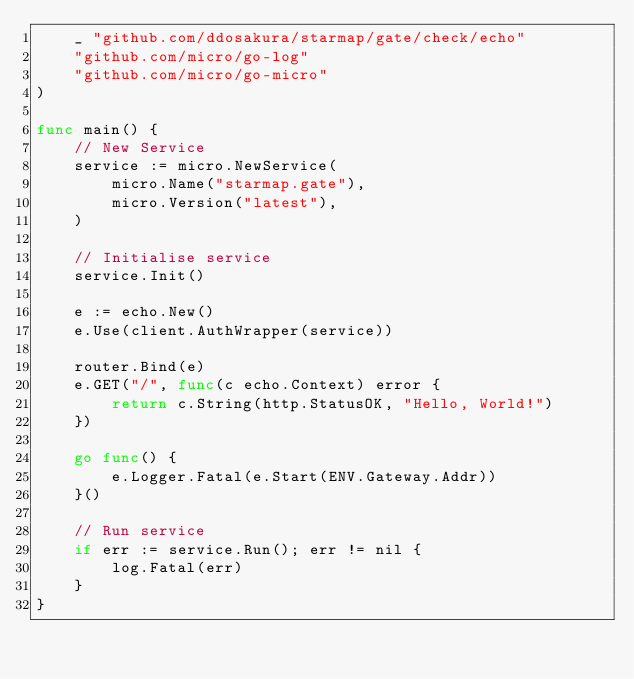<code> <loc_0><loc_0><loc_500><loc_500><_Go_>	_ "github.com/ddosakura/starmap/gate/check/echo"
	"github.com/micro/go-log"
	"github.com/micro/go-micro"
)

func main() {
	// New Service
	service := micro.NewService(
		micro.Name("starmap.gate"),
		micro.Version("latest"),
	)

	// Initialise service
	service.Init()

	e := echo.New()
	e.Use(client.AuthWrapper(service))

	router.Bind(e)
	e.GET("/", func(c echo.Context) error {
		return c.String(http.StatusOK, "Hello, World!")
	})

	go func() {
		e.Logger.Fatal(e.Start(ENV.Gateway.Addr))
	}()

	// Run service
	if err := service.Run(); err != nil {
		log.Fatal(err)
	}
}
</code> 